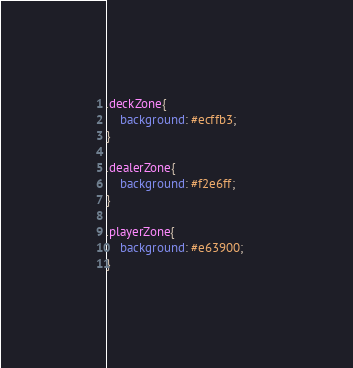Convert code to text. <code><loc_0><loc_0><loc_500><loc_500><_CSS_>.deckZone{
	background: #ecffb3;
}

.dealerZone{
	background: #f2e6ff;	
}

.playerZone{
	background: #e63900;	
}</code> 